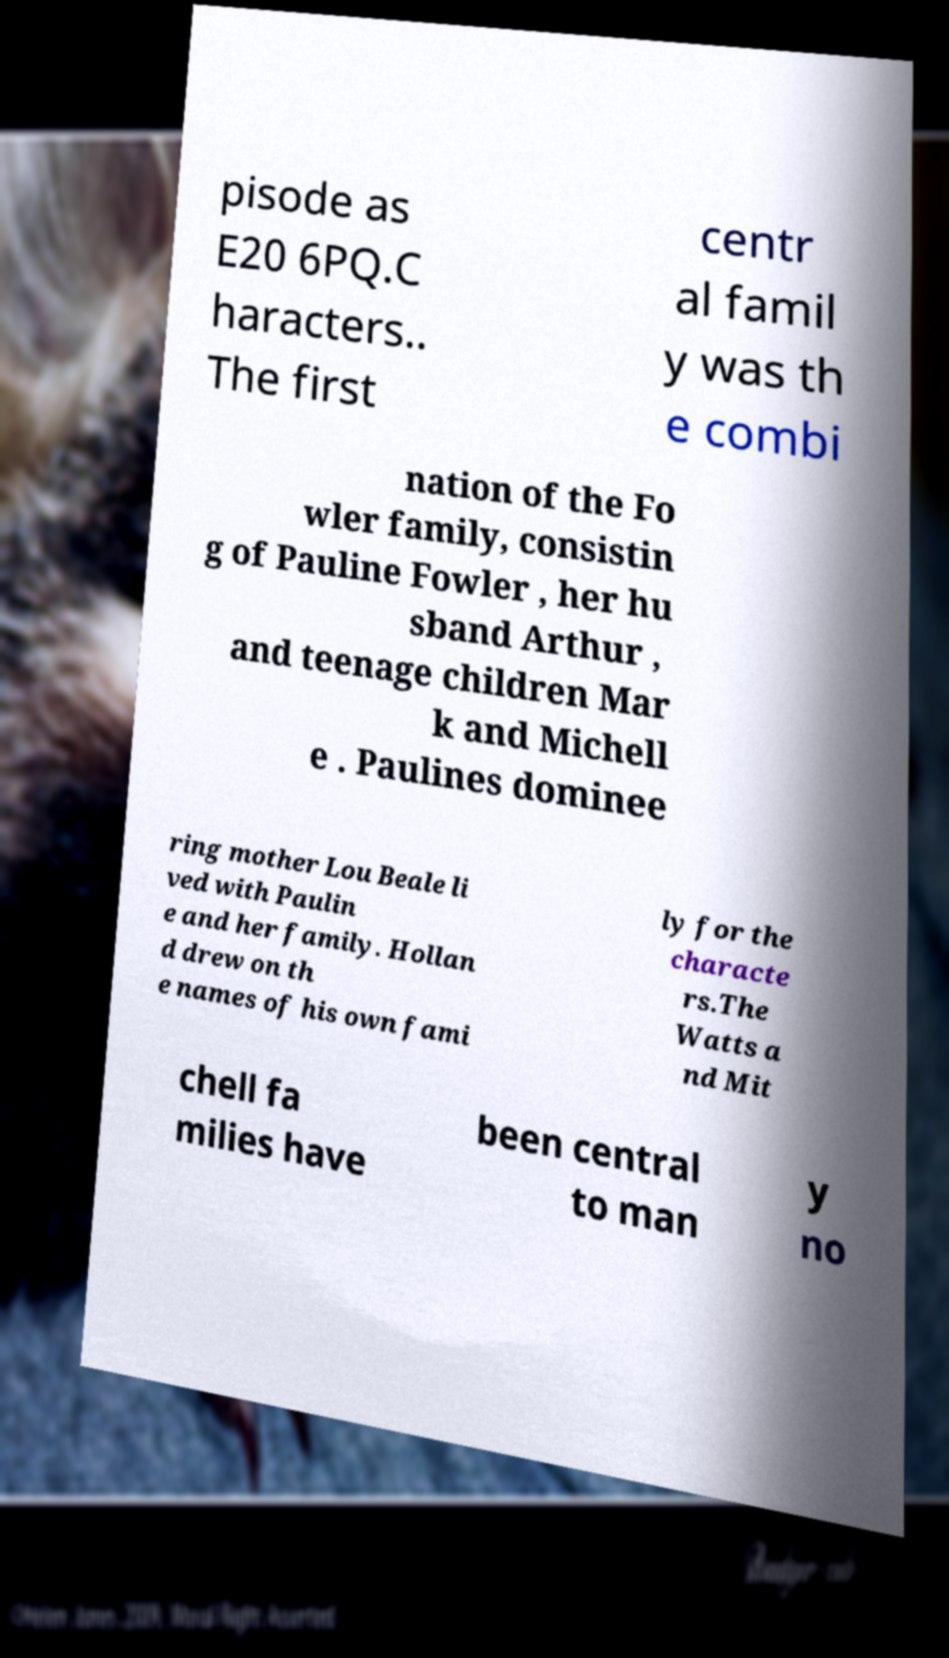Can you accurately transcribe the text from the provided image for me? pisode as E20 6PQ.C haracters.. The first centr al famil y was th e combi nation of the Fo wler family, consistin g of Pauline Fowler , her hu sband Arthur , and teenage children Mar k and Michell e . Paulines dominee ring mother Lou Beale li ved with Paulin e and her family. Hollan d drew on th e names of his own fami ly for the characte rs.The Watts a nd Mit chell fa milies have been central to man y no 